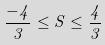<formula> <loc_0><loc_0><loc_500><loc_500>\frac { - 4 } { 3 } \leq S \leq \frac { 4 } { 3 }</formula> 